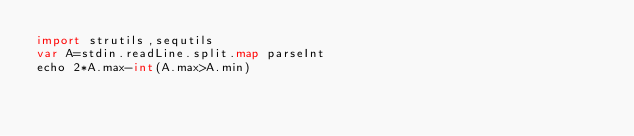<code> <loc_0><loc_0><loc_500><loc_500><_Nim_>import strutils,sequtils
var A=stdin.readLine.split.map parseInt
echo 2*A.max-int(A.max>A.min)</code> 